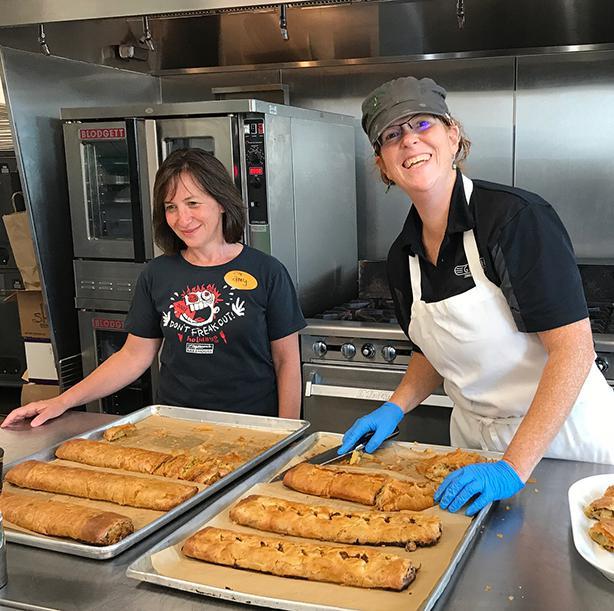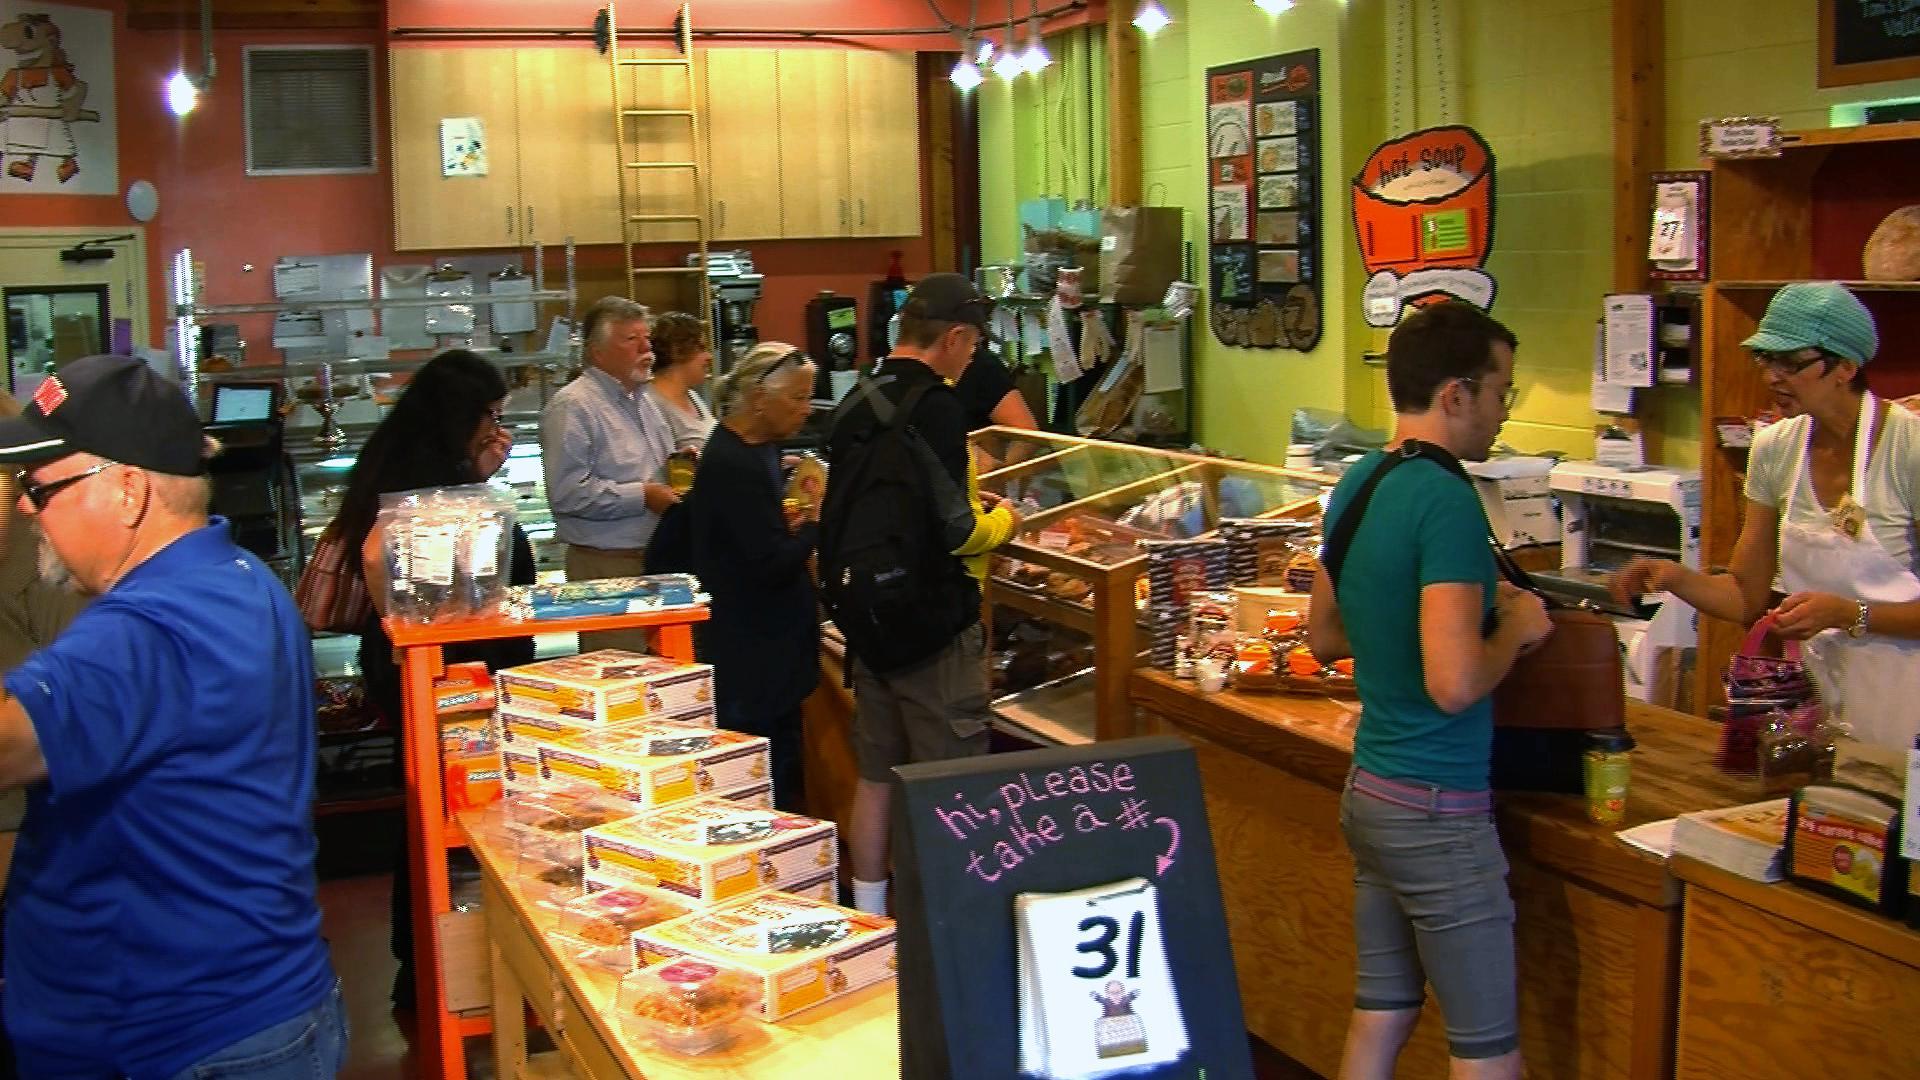The first image is the image on the left, the second image is the image on the right. For the images displayed, is the sentence "There are exactly two people in the left image." factually correct? Answer yes or no. Yes. The first image is the image on the left, the second image is the image on the right. Assess this claim about the two images: "The rack of bread in one image is flanked by two people in aprons.". Correct or not? Answer yes or no. No. 